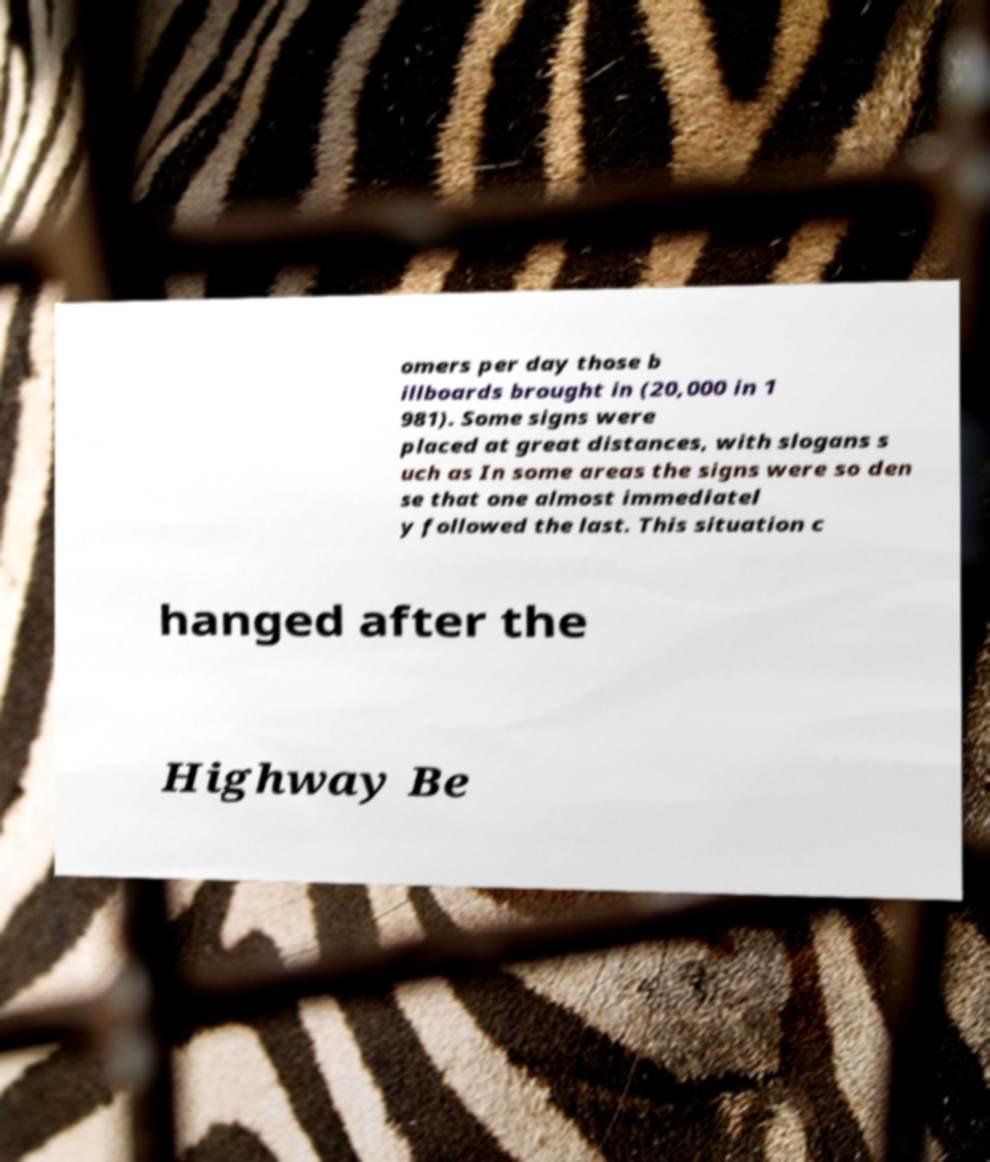Can you read and provide the text displayed in the image?This photo seems to have some interesting text. Can you extract and type it out for me? omers per day those b illboards brought in (20,000 in 1 981). Some signs were placed at great distances, with slogans s uch as In some areas the signs were so den se that one almost immediatel y followed the last. This situation c hanged after the Highway Be 